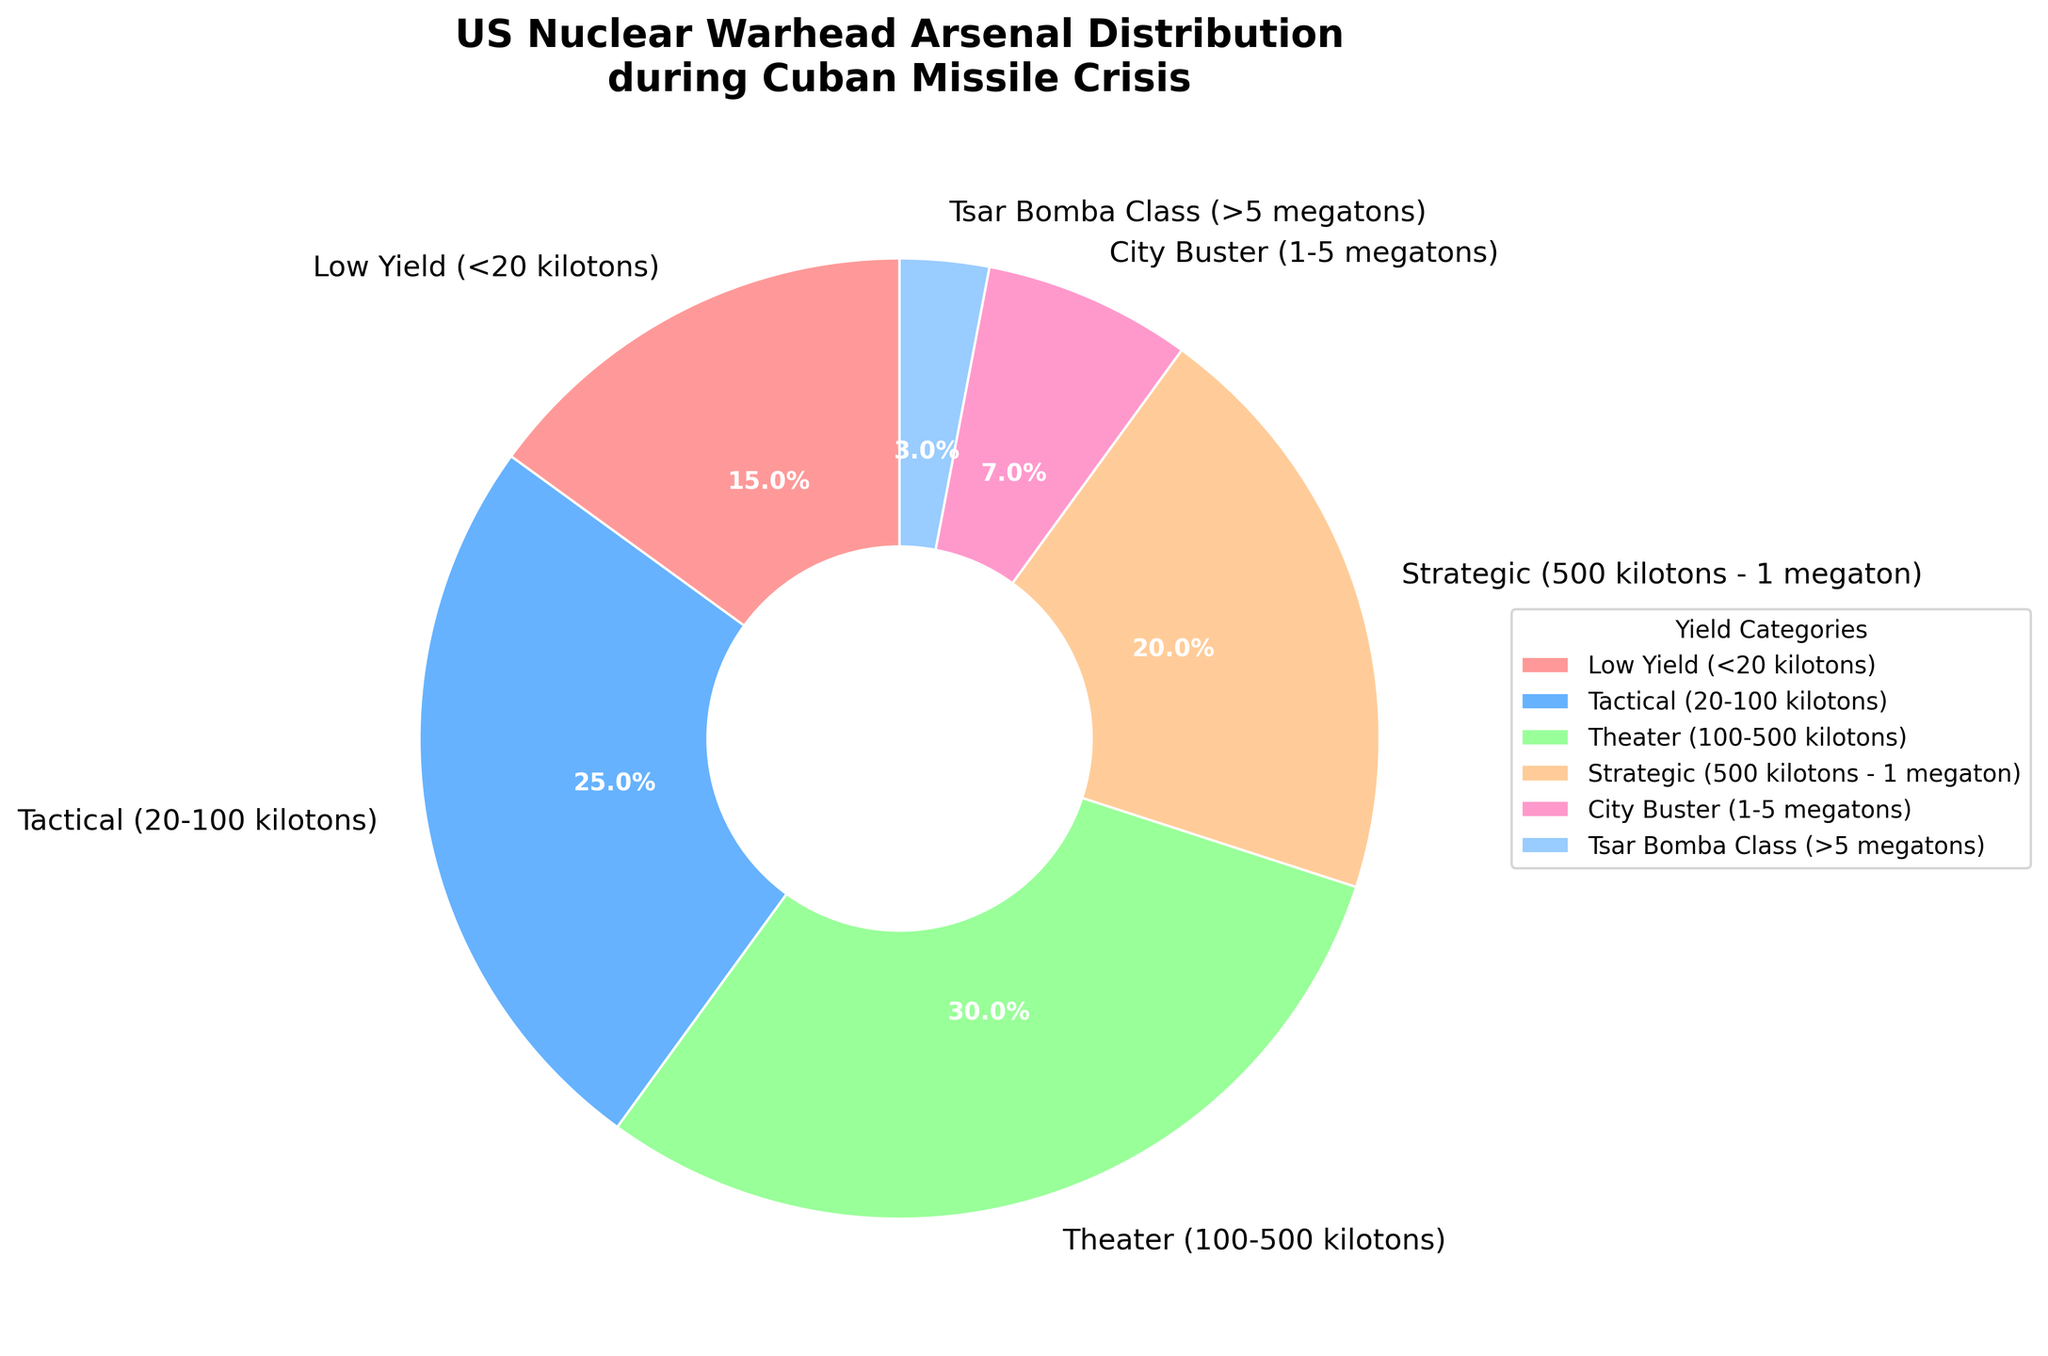Which yield category has the largest proportion? The category with the largest proportion is the one with the highest percentage value in the figure. In this case, it's the Theater category with 30%.
Answer: Theater category (30%) Which yield category has the smallest proportion? The category with the smallest proportion is identified by the lowest percentage value in the chart. Here, it is the Tsar Bomba Class with 3%.
Answer: Tsar Bomba Class (3%) What is the combined proportion of the Low Yield and Tactical categories? To find this, sum up the percentages of the Low Yield and Tactical categories from the chart. Low Yield is 15% and Tactical is 25%. 15% + 25% = 40%
Answer: 40% How much larger is the proportion of the Theater category compared to the City Buster category? Calculate the difference in percentage between the Theater and City Buster categories. Theater is 30%, and City Buster is 7%. 30% - 7% = 23%
Answer: 23% Which color corresponds to the City Buster category? Identify the color used in the pie chart for the City Buster category. In this chart, the City Buster category is represented by pink.
Answer: Pink If the combined proportion of Strategic and City Buster categories is less than 30%, what is the combined proportion? Check the individual proportions of Strategic (20%) and City Buster (7%) categories and sum them up. 20% + 7% = 27%, which is less than 30%.
Answer: 27% Are there more warheads in the Tactical or Strategic category? Compare the percentages of the Tactical (25%) and Strategic (20%) categories from the chart. The Tactical category has a higher proportion than the Strategic category.
Answer: Tactical category (25%) Which category is represented by the second largest wedge in the pie chart? Identify the second largest percentage value in the pie chart, which corresponds to the Tactical category with 25%.
Answer: Tactical category (25%) What percentage of warheads are in categories with yields greater than 1 megaton? Add the percentages of the City Buster (1-5 megatons) and Tsar Bomba Class (>5 megatons) categories. 7% + 3% = 10%
Answer: 10% Which category shown in the legend is located at the bottom of the pie chart? Observe the wedge colors and the corresponding categories to find which category is located at the bottom of the pie chart. The Tactical (blue color) is at the bottom.
Answer: Tactical category (blue) 